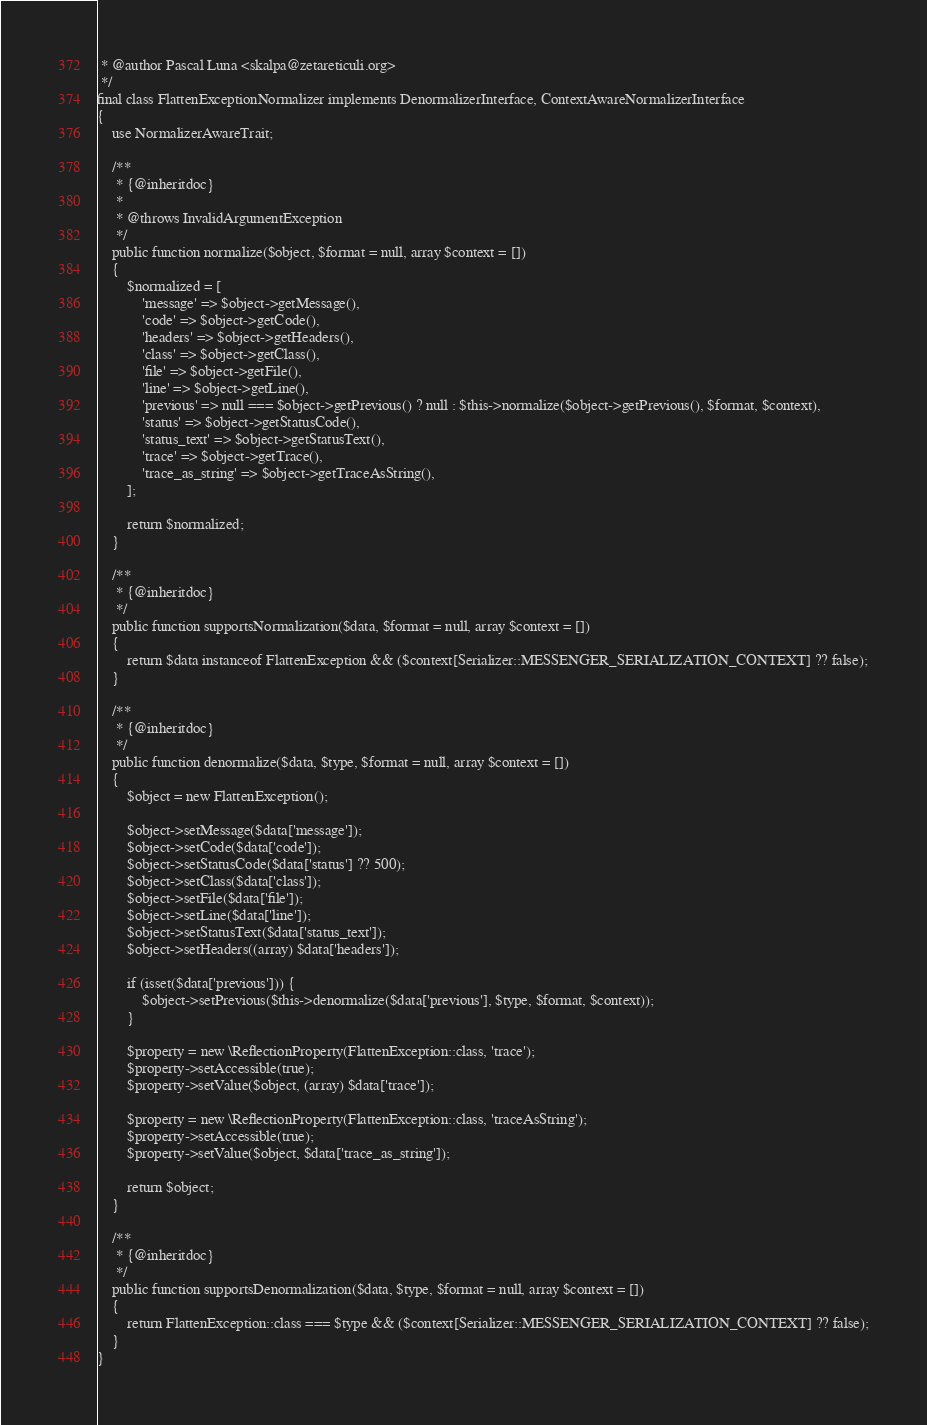Convert code to text. <code><loc_0><loc_0><loc_500><loc_500><_PHP_> * @author Pascal Luna <skalpa@zetareticuli.org>
 */
final class FlattenExceptionNormalizer implements DenormalizerInterface, ContextAwareNormalizerInterface
{
    use NormalizerAwareTrait;

    /**
     * {@inheritdoc}
     *
     * @throws InvalidArgumentException
     */
    public function normalize($object, $format = null, array $context = [])
    {
        $normalized = [
            'message' => $object->getMessage(),
            'code' => $object->getCode(),
            'headers' => $object->getHeaders(),
            'class' => $object->getClass(),
            'file' => $object->getFile(),
            'line' => $object->getLine(),
            'previous' => null === $object->getPrevious() ? null : $this->normalize($object->getPrevious(), $format, $context),
            'status' => $object->getStatusCode(),
            'status_text' => $object->getStatusText(),
            'trace' => $object->getTrace(),
            'trace_as_string' => $object->getTraceAsString(),
        ];

        return $normalized;
    }

    /**
     * {@inheritdoc}
     */
    public function supportsNormalization($data, $format = null, array $context = [])
    {
        return $data instanceof FlattenException && ($context[Serializer::MESSENGER_SERIALIZATION_CONTEXT] ?? false);
    }

    /**
     * {@inheritdoc}
     */
    public function denormalize($data, $type, $format = null, array $context = [])
    {
        $object = new FlattenException();

        $object->setMessage($data['message']);
        $object->setCode($data['code']);
        $object->setStatusCode($data['status'] ?? 500);
        $object->setClass($data['class']);
        $object->setFile($data['file']);
        $object->setLine($data['line']);
        $object->setStatusText($data['status_text']);
        $object->setHeaders((array) $data['headers']);

        if (isset($data['previous'])) {
            $object->setPrevious($this->denormalize($data['previous'], $type, $format, $context));
        }

        $property = new \ReflectionProperty(FlattenException::class, 'trace');
        $property->setAccessible(true);
        $property->setValue($object, (array) $data['trace']);

        $property = new \ReflectionProperty(FlattenException::class, 'traceAsString');
        $property->setAccessible(true);
        $property->setValue($object, $data['trace_as_string']);

        return $object;
    }

    /**
     * {@inheritdoc}
     */
    public function supportsDenormalization($data, $type, $format = null, array $context = [])
    {
        return FlattenException::class === $type && ($context[Serializer::MESSENGER_SERIALIZATION_CONTEXT] ?? false);
    }
}
</code> 